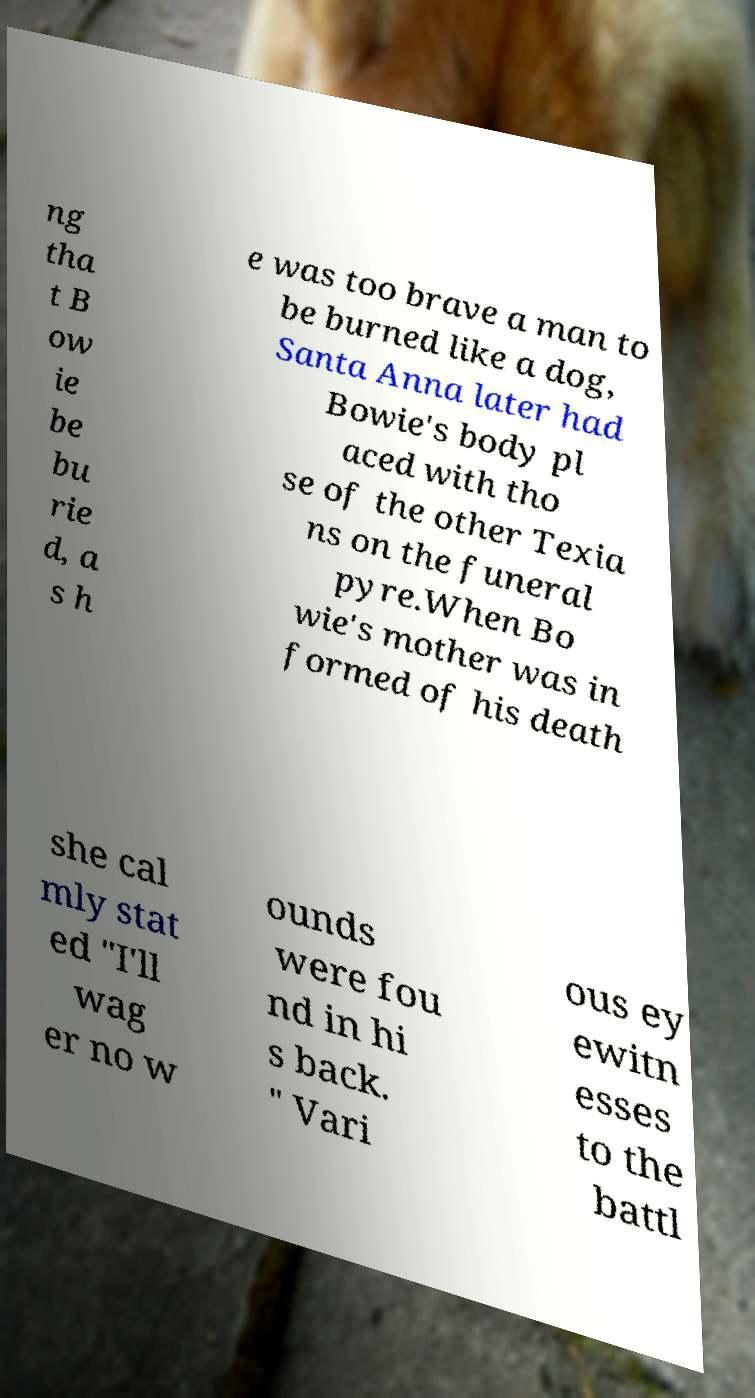Please read and relay the text visible in this image. What does it say? ng tha t B ow ie be bu rie d, a s h e was too brave a man to be burned like a dog, Santa Anna later had Bowie's body pl aced with tho se of the other Texia ns on the funeral pyre.When Bo wie's mother was in formed of his death she cal mly stat ed "I'll wag er no w ounds were fou nd in hi s back. " Vari ous ey ewitn esses to the battl 